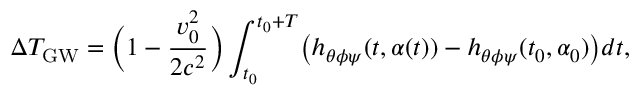<formula> <loc_0><loc_0><loc_500><loc_500>\Delta T _ { G W } = \left ( 1 - \frac { v _ { 0 } ^ { 2 } } { 2 c ^ { 2 } } \right ) \int _ { t _ { 0 } } ^ { t _ { 0 } + T } \left ( h _ { \theta \phi \psi } ( t , \alpha ( t ) ) - h _ { \theta \phi \psi } ( t _ { 0 } , \alpha _ { 0 } ) \right ) d t ,</formula> 